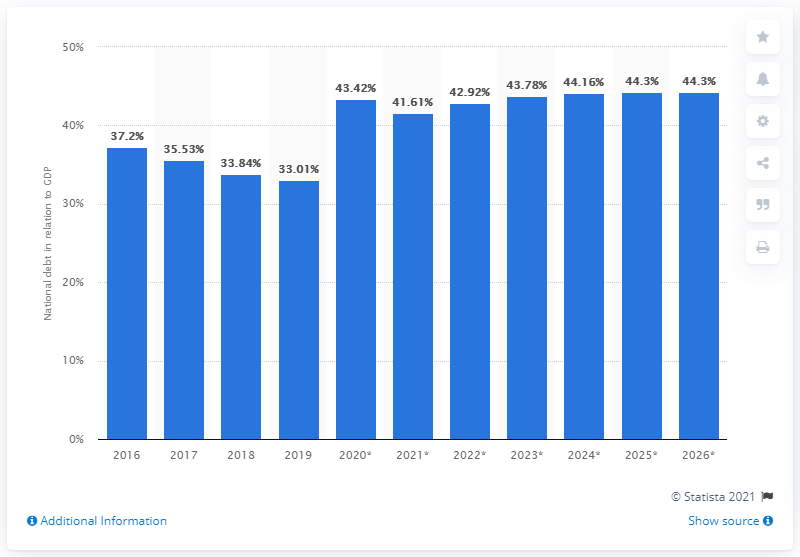Point out several critical features in this image. In 2019, the national debt of Denmark accounted for approximately 33.01% of the country's Gross Domestic Product (GDP). 